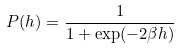<formula> <loc_0><loc_0><loc_500><loc_500>P ( h ) = \frac { 1 } { 1 + \exp ( - 2 \beta h ) }</formula> 